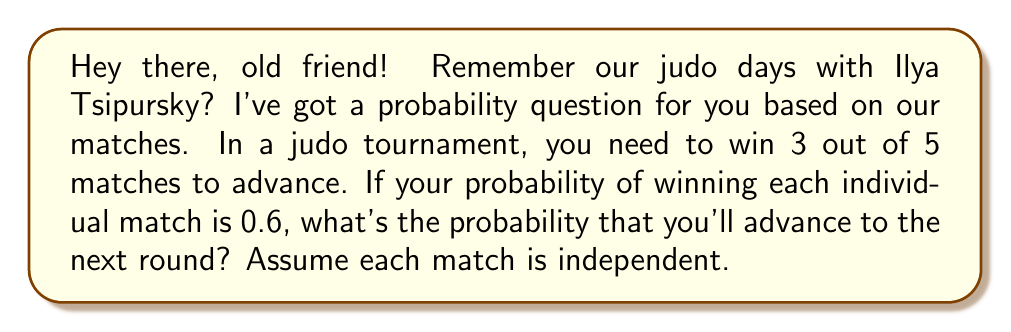Teach me how to tackle this problem. Let's approach this step-by-step:

1) To advance, you need to win at least 3 out of 5 matches. This can happen in three ways:
   - Win exactly 3 matches (and lose 2)
   - Win exactly 4 matches (and lose 1)
   - Win all 5 matches

2) Let's calculate the probability of each scenario:

   a) Probability of winning exactly 3 matches:
      $${5 \choose 3} \cdot 0.6^3 \cdot 0.4^2$$
      
      Here, ${5 \choose 3}$ is the number of ways to choose 3 matches out of 5.
      
   b) Probability of winning exactly 4 matches:
      $${5 \choose 4} \cdot 0.6^4 \cdot 0.4^1$$
      
   c) Probability of winning all 5 matches:
      $${5 \choose 5} \cdot 0.6^5 \cdot 0.4^0$$

3) Now, let's calculate each of these:

   a) ${5 \choose 3} \cdot 0.6^3 \cdot 0.4^2 = 10 \cdot 0.216 \cdot 0.16 = 0.3456$
   
   b) ${5 \choose 4} \cdot 0.6^4 \cdot 0.4^1 = 5 \cdot 0.1296 \cdot 0.4 = 0.2592$
   
   c) ${5 \choose 5} \cdot 0.6^5 \cdot 0.4^0 = 1 \cdot 0.07776 \cdot 1 = 0.07776$

4) The total probability of advancing is the sum of these probabilities:

   $0.3456 + 0.2592 + 0.07776 = 0.68256$
Answer: The probability of advancing to the next round is approximately 0.6826 or 68.26%. 